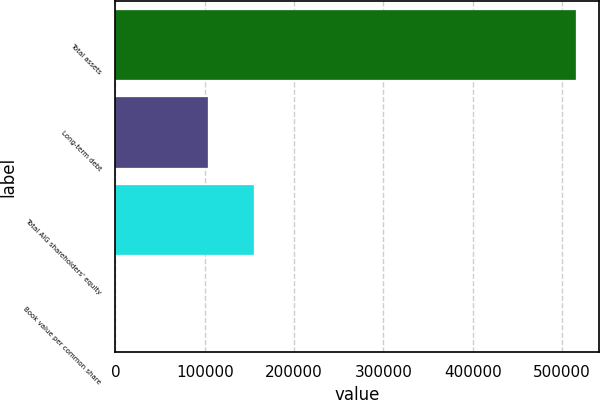<chart> <loc_0><loc_0><loc_500><loc_500><bar_chart><fcel>Total assets<fcel>Long-term debt<fcel>Total AIG shareholders' equity<fcel>Book value per common share<nl><fcel>515581<fcel>103172<fcel>154723<fcel>69.98<nl></chart> 